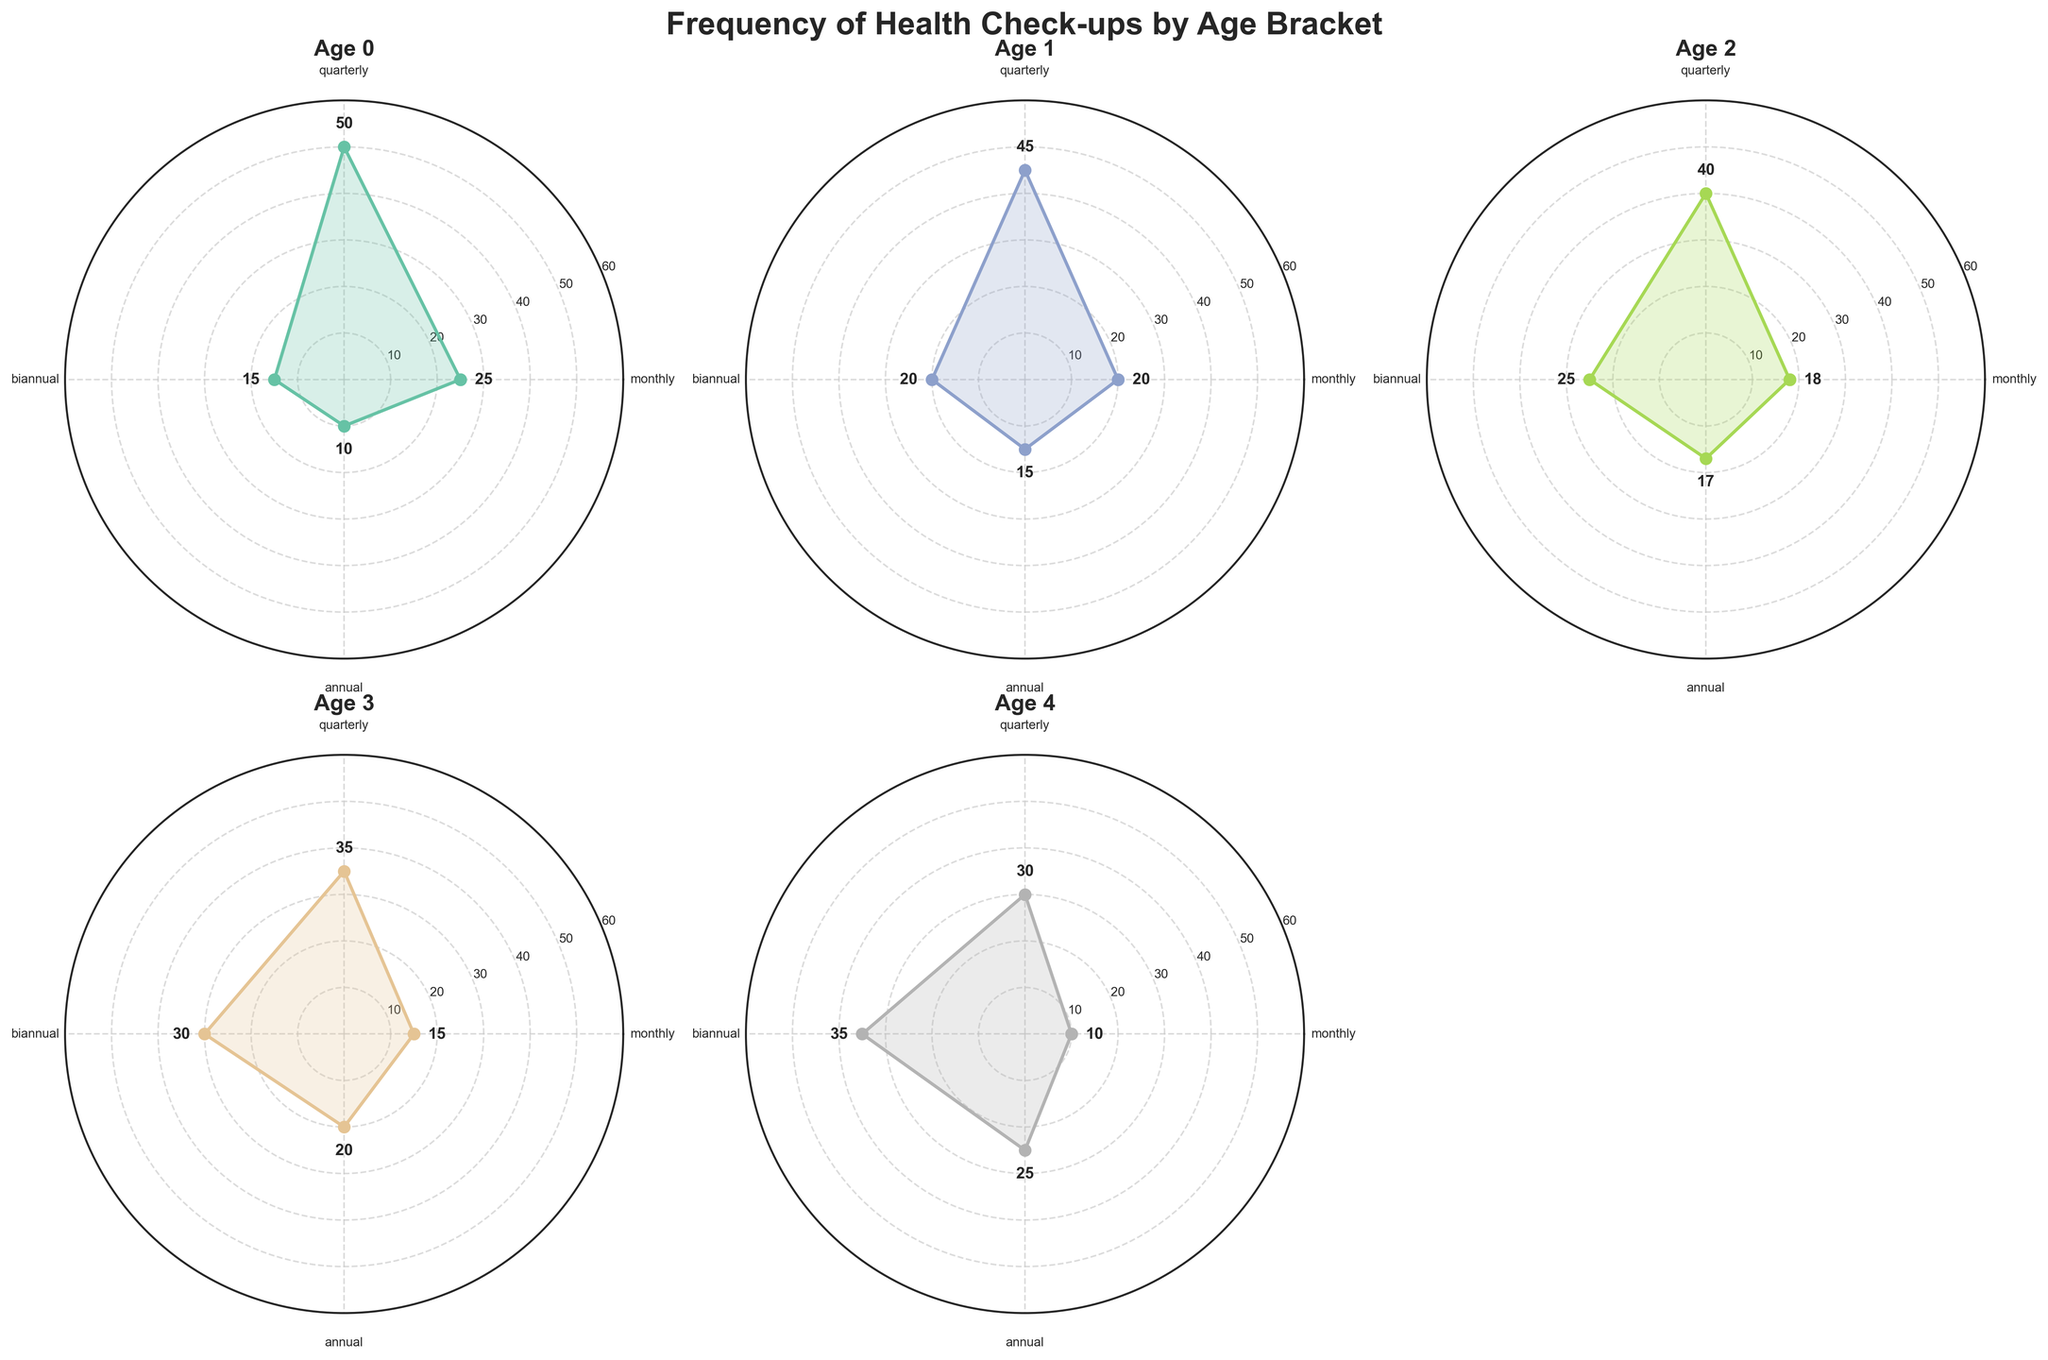How often do people aged 65-69 get monthly health check-ups? Count the data points corresponding to 'monthly' for the 65-69 age bracket, which is shown in the chart as a number near the edge in the first subplot.
Answer: 25 Which age group has the highest frequency of annual health check-ups? Identify the subplot for each age bracket and look for the 'annual' values. The highest value is seen in the 85+ age bracket.
Answer: 85+ Does the frequency of biannual health check-ups increase or decrease with age? Track the line corresponding to 'biannual' across each age group's subplot. As age increases, the biannual frequency also increases.
Answer: Increase What is the average frequency of quarterly health check-ups for people aged 75-79? From the subplot for age 75-79, observe the quarterly data point (40). Since it's the only value for this age bracket, the average is the same.
Answer: 40 Compare the frequency of quarterly health check-ups between people aged 70-74 and 80-84. Who has higher frequency? Locate the 'quarterly' values for both age brackets (70-74: 45 and 80-84: 35). The frequency is higher for those aged 70-74.
Answer: 70-74 For which age range is the difference between monthly and annual health check-up frequencies the greatest? Calculate the difference for each subplot: 65-69 (25-10=15), 70-74 (20-15=5), 75-79 (18-17=1), 80-84 (15-20=-5), 85+ (10-25=-15). The greatest absolute value of this difference is for 65-69.
Answer: 65-69 How does the frequency of biannual health check-ups for 85+ compare to 70-74? Observe and compare the 'biannual' values for these age brackets (85+: 35, 70-74: 20). The 85+ age bracket has higher frequency.
Answer: Higher What can you infer about the overall trend in frequency of health check-ups with age? By observing each subplot, the trend generally shows an increase in biannual and annual frequencies with age and a decrease in monthly check-ups.
Answer: Biannual and annual increase; monthly decrease Which age bracket has the most even distribution of health check-up frequencies across all categories? Compare the height (frequencies) of each category within subplots: 65-69 (spread: 25-10), 70-74 (spread: 20-15), 75-79 (spread: 18-17), 80-84 (spread: 15-20), 85+ (spread: 10-25). The 75-79 age group has the smallest spread (1).
Answer: 75-79 